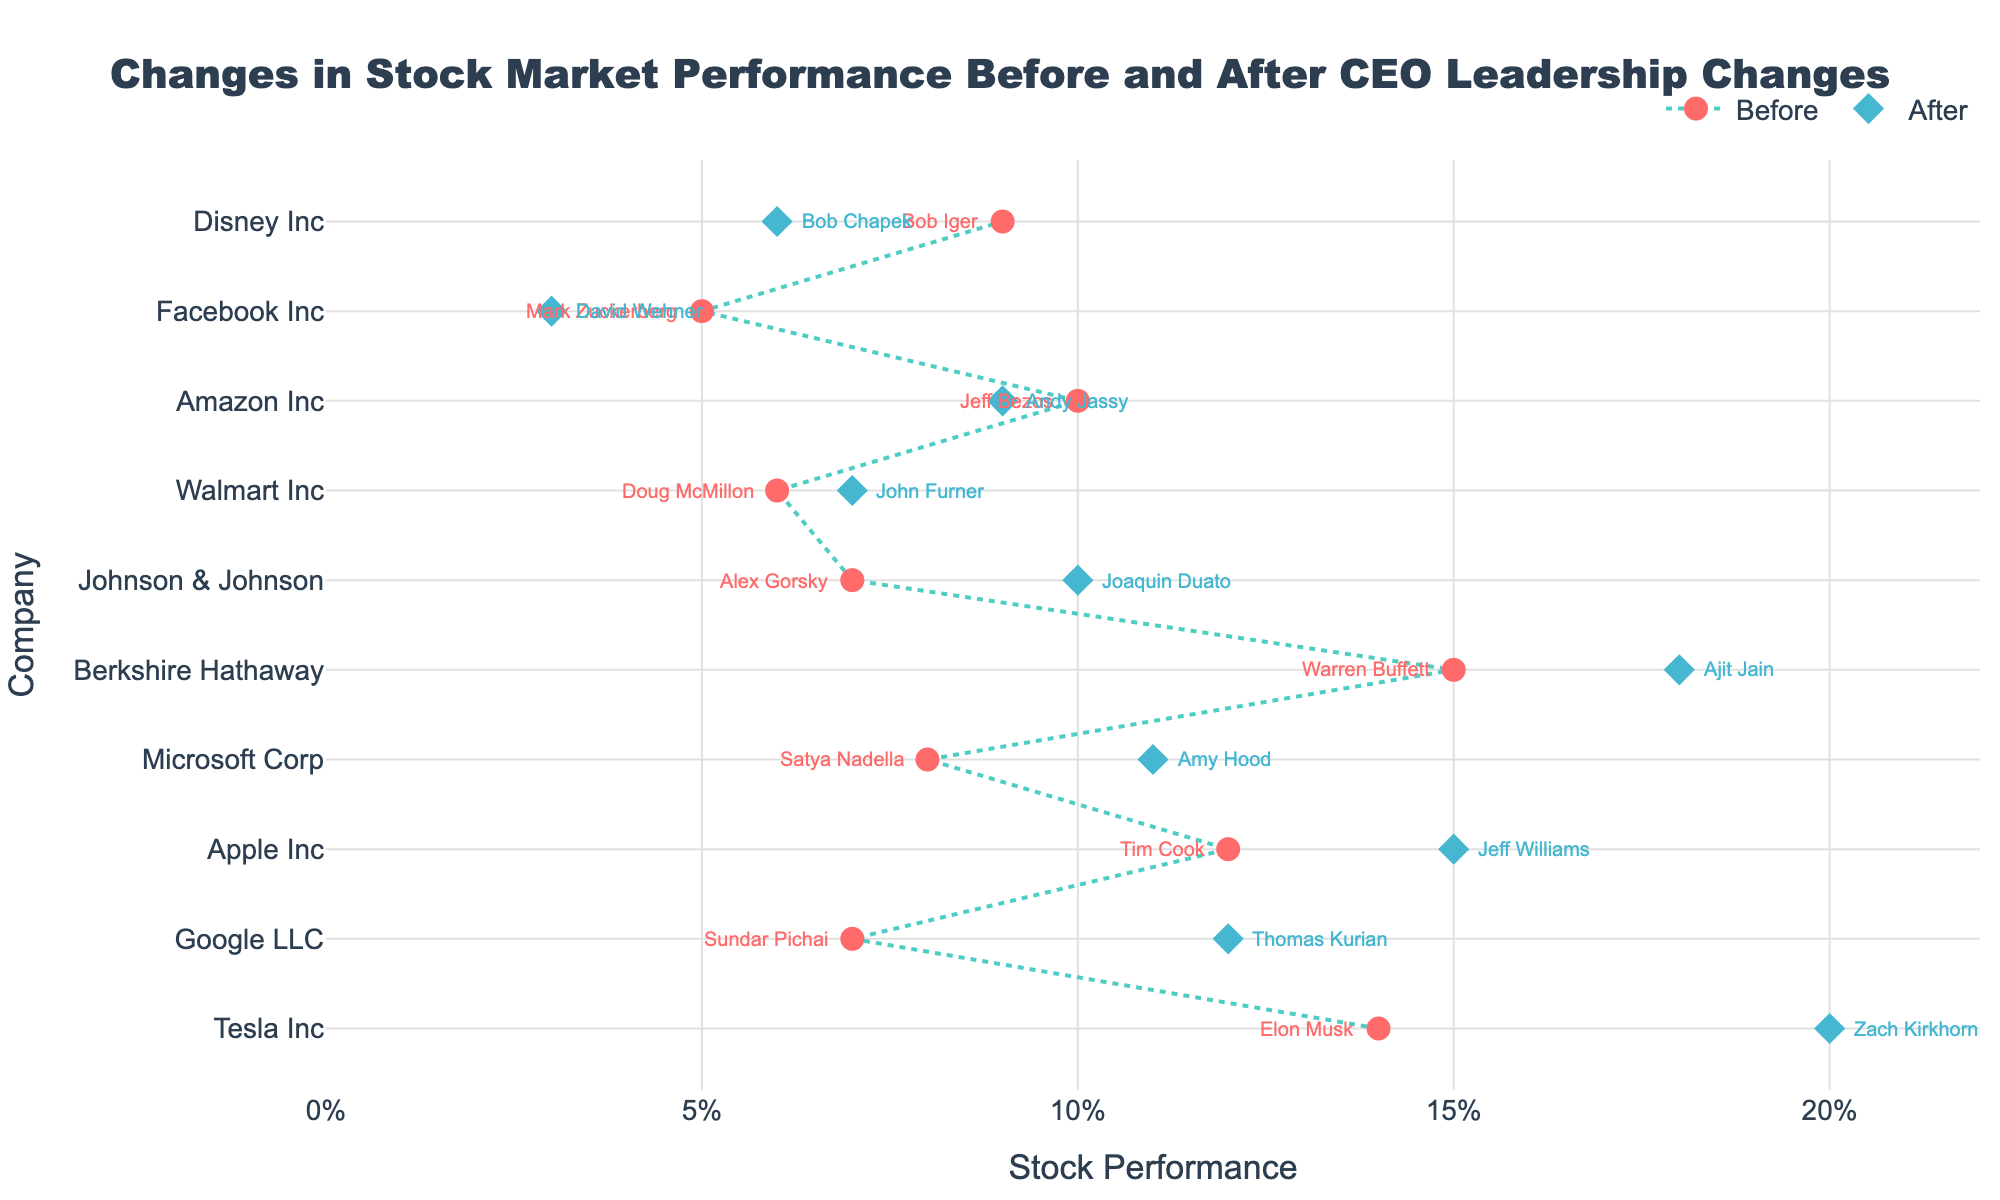Is there a noticeable trend in stock performance after the new CEOs took over? By inspecting the lines between the circles and diamonds, it is evident that most companies have seen improvements in stock performance, as indicated by upward-sloping lines.
Answer: Yes Which company experienced the largest increase in stock performance after the CEO change? The company with the largest vertical distance between the two markers (circles and diamonds) is Tesla Inc.
Answer: Tesla Inc How did Facebook Inc.'s stock performance change under new leadership? The diamond marker for new performance is below the circle marker for old performance in Facebook's line, indicating a drop.
Answer: Decreased Which two companies have the smallest difference in stock performance before and after the CEO change? The shortest lines in the plot reflect minimal differences in performance. These lines belong to Amazon Inc. and Walmart Inc.
Answer: Amazon Inc. and Walmart Inc How many companies show an improvement in stock performance after the CEO change? Count the number of lines where the diamond marker is to the right of the circle marker, indicating better performance. There are 7 such companies.
Answer: 7 Who was the CEO of Berkshire Hathaway before the current one? Referring to the annotation next to the circle marker for Berkshire Hathaway shows the old CEO's name as Warren Buffett.
Answer: Warren Buffett Did Google's stock performance improve or decline after the new CEO took over? The diamond marker for the new performance is to the right of the circle marker for the old performance in Google's line, indicating an improvement.
Answer: Improved Which company's new CEO appears to have led to the biggest performance improvement? The biggest vertical leap from circle to diamond marker on the plot is observed for Tesla Inc., suggesting the greatest improvement.
Answer: Tesla Inc What was the stock performance of Disney Inc. before the CEO change? By looking at the circle marker on Disney Inc.'s line, it is located at the 0.09 mark on the x-axis.
Answer: 0.09 Among the listed companies, which one had the highest stock performance before any CEO change? By examining the highest circle marker on the x-axis, Berkshire Hathaway's marker is at 0.15, the highest before any CEO change.
Answer: Berkshire Hathaway 